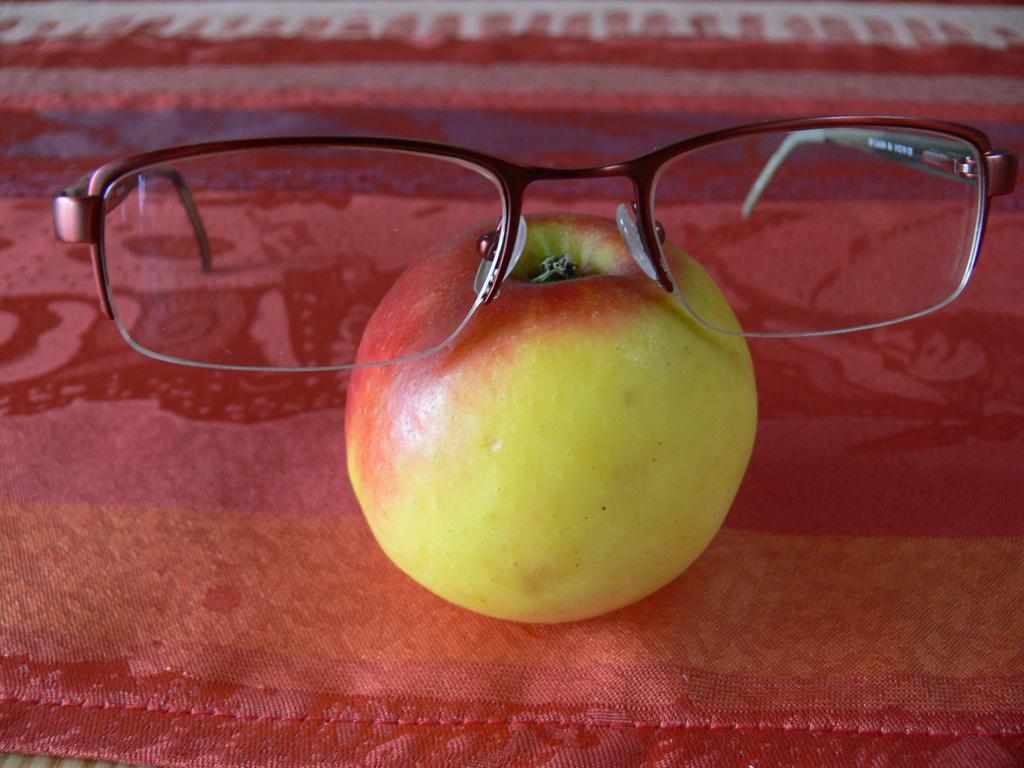Please provide a concise description of this image. In the image there is a fruit and on the fruit there are spectacles. 